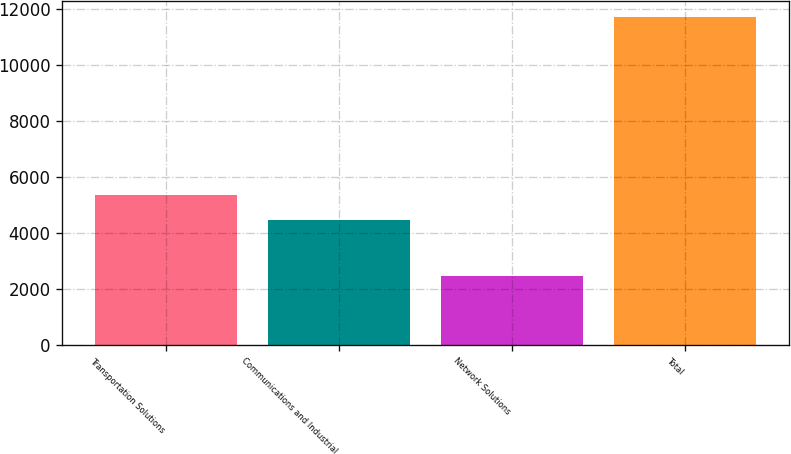Convert chart. <chart><loc_0><loc_0><loc_500><loc_500><bar_chart><fcel>Transportation Solutions<fcel>Communications and Industrial<fcel>Network Solutions<fcel>Total<nl><fcel>5354<fcel>4431<fcel>2451<fcel>11681<nl></chart> 